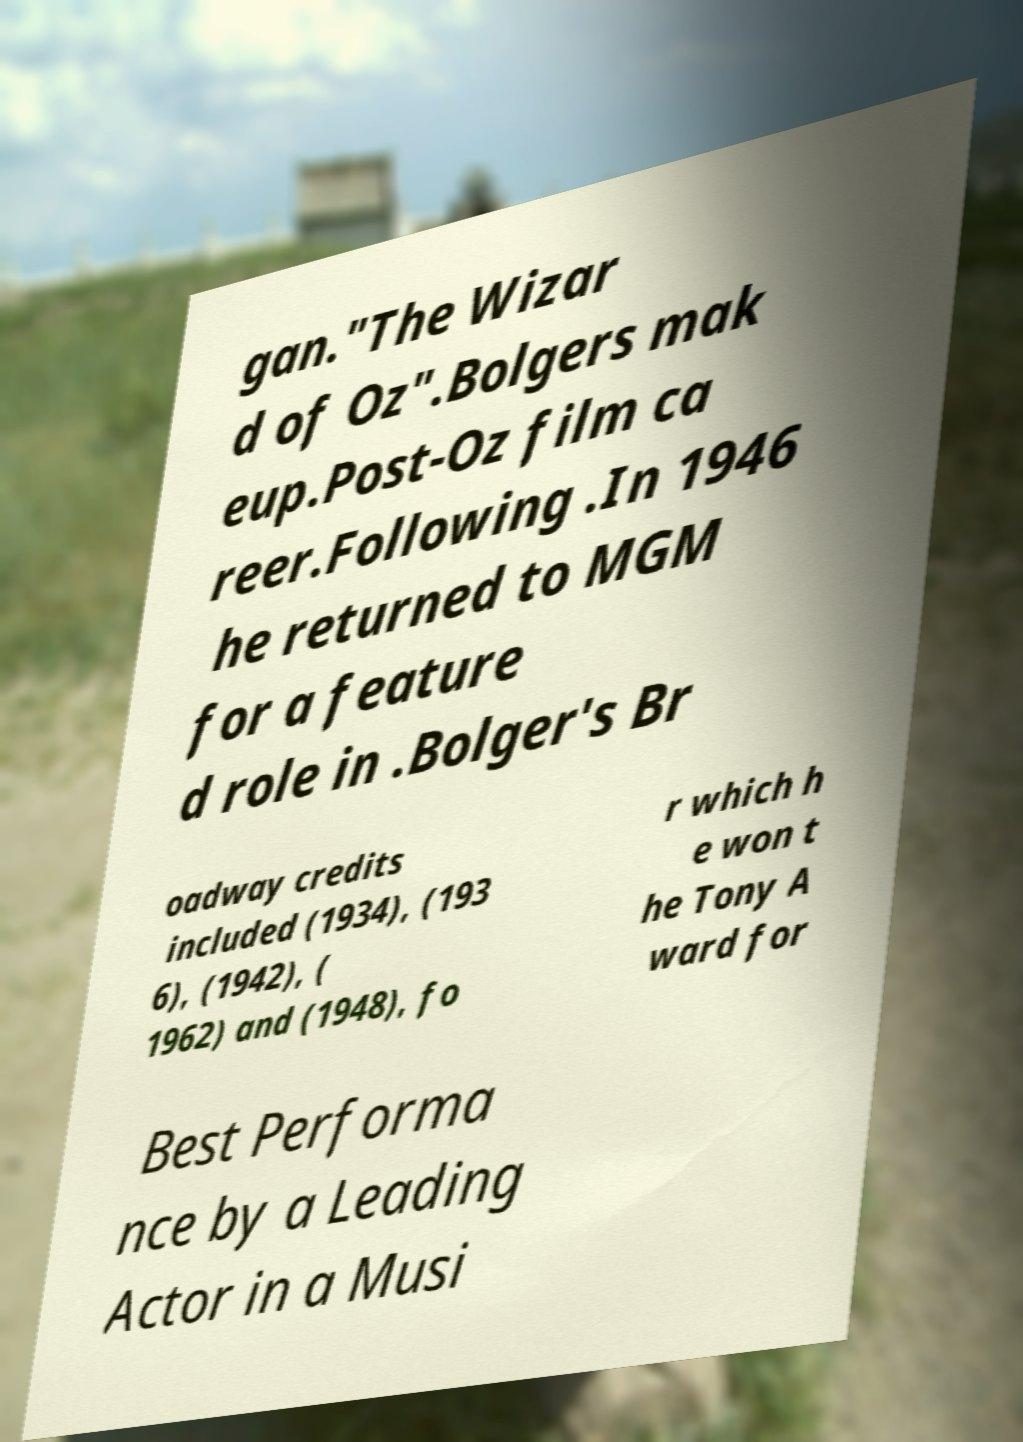What messages or text are displayed in this image? I need them in a readable, typed format. gan."The Wizar d of Oz".Bolgers mak eup.Post-Oz film ca reer.Following .In 1946 he returned to MGM for a feature d role in .Bolger's Br oadway credits included (1934), (193 6), (1942), ( 1962) and (1948), fo r which h e won t he Tony A ward for Best Performa nce by a Leading Actor in a Musi 